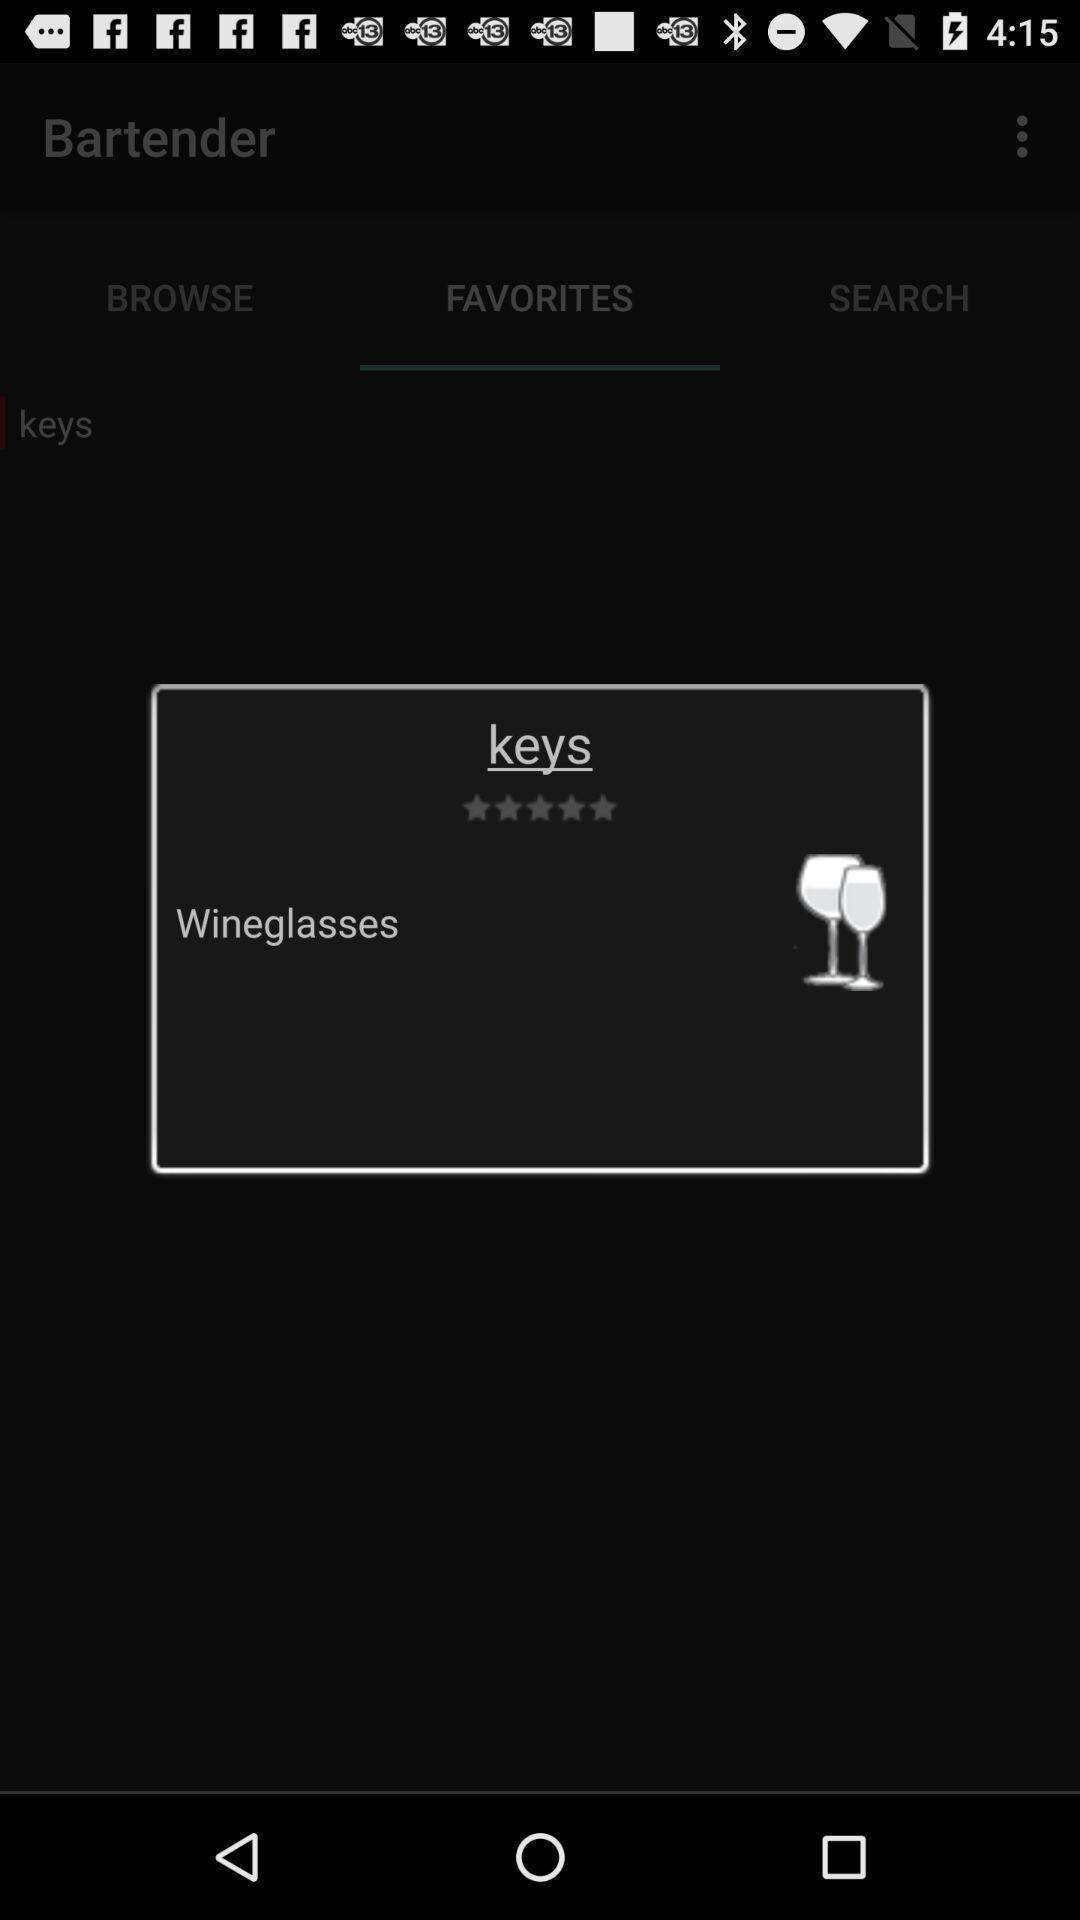Provide a textual representation of this image. Pop up asking to rate bartender. 